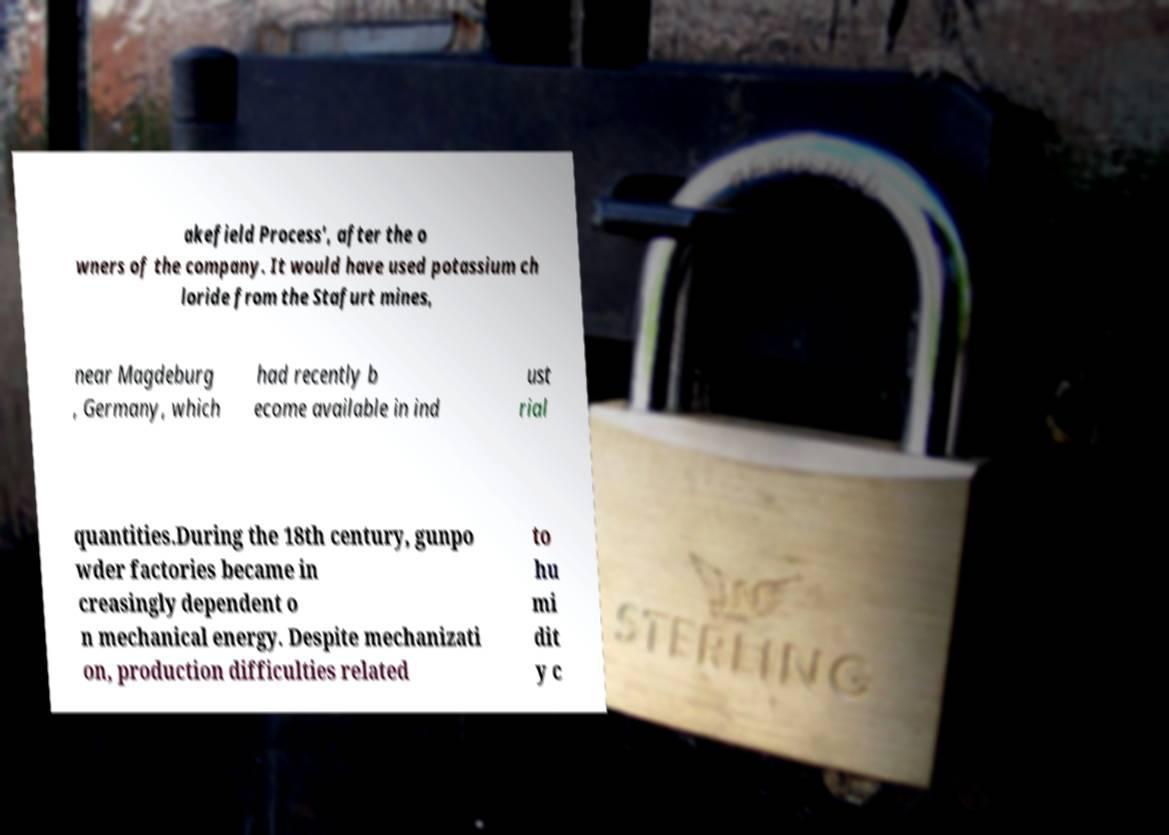Could you assist in decoding the text presented in this image and type it out clearly? akefield Process', after the o wners of the company. It would have used potassium ch loride from the Stafurt mines, near Magdeburg , Germany, which had recently b ecome available in ind ust rial quantities.During the 18th century, gunpo wder factories became in creasingly dependent o n mechanical energy. Despite mechanizati on, production difficulties related to hu mi dit y c 